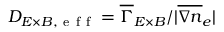<formula> <loc_0><loc_0><loc_500><loc_500>D _ { E \times B , e f f } = \overline { \Gamma } _ { E \times B } / | \overline { \nabla n } _ { e } |</formula> 